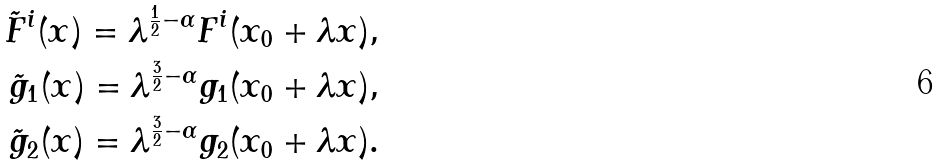<formula> <loc_0><loc_0><loc_500><loc_500>\tilde { F } ^ { i } ( x ) = \lambda ^ { \frac { 1 } { 2 } - \alpha } F ^ { i } ( x _ { 0 } + \lambda x ) , \\ \tilde { g } _ { 1 } ( x ) = \lambda ^ { \frac { 3 } { 2 } - \alpha } g _ { 1 } ( x _ { 0 } + \lambda x ) , \\ \tilde { g } _ { 2 } ( x ) = \lambda ^ { \frac { 3 } { 2 } - \alpha } g _ { 2 } ( x _ { 0 } + \lambda x ) .</formula> 